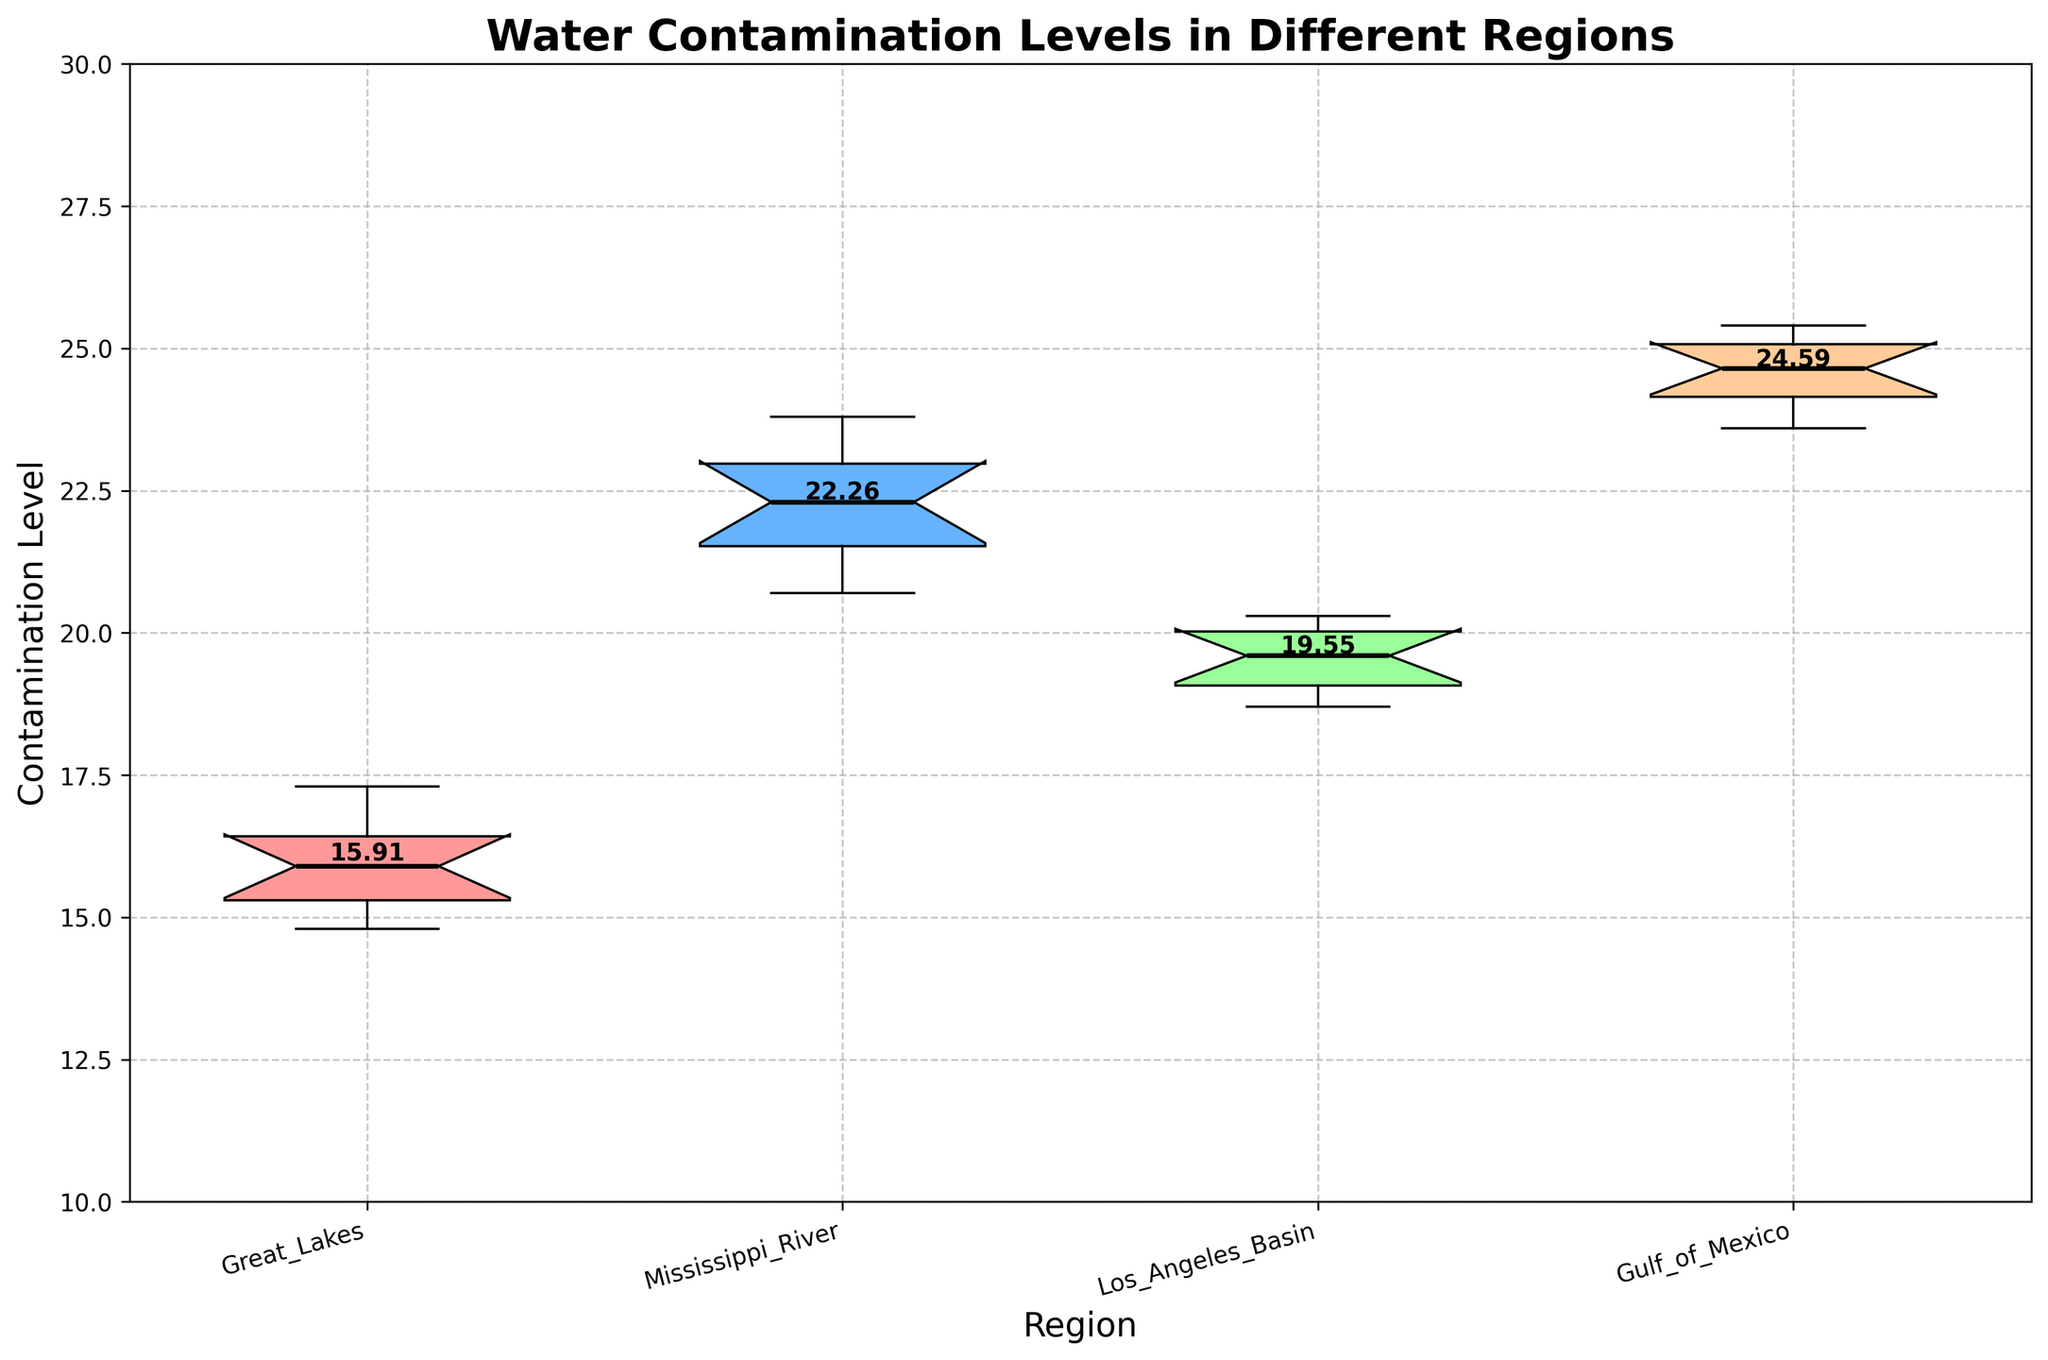What is the title of the figure? The title is written at the top of the figure and summarizes the content of the visualization.
Answer: Water Contamination Levels in Different Regions What is the contamination level at the median for the Great Lakes region? In a notched box plot, the median is indicated by the line inside the box and for the Great Lakes region, it is the middle of the first box from the left.
Answer: 16.0 Which region has the highest median contamination level? By looking at the lines inside the boxes, the Gulf of Mexico has the highest median, as it is the tallest among the medians of all regions.
Answer: Gulf of Mexico Which region has the lowest range of contamination levels? The range can be determined by the difference between the top and bottom of the box. The Great Lakes region has the smallest vertical span of the box, indicating the lowest range.
Answer: Great Lakes How do the average contamination levels compare between the Mississippi River and the Great Lakes regions? The average level for each region is indicated numerically above or below the box plot. The averages can be compared by noting the labels provided: Mississippi River (22.25) and Great Lakes (15.91).
Answer: Mississippi River has a higher average What is the interquartile range (IQR) for the Los Angeles Basin? The IQR is the difference between the third quartile (top of the box) and the first quartile (bottom of the box) in a box plot. For the Los Angeles Basin, identify these points visually from the box.
Answer: 1.3 (20.2 - 18.9) Which region shows the most variation in contamination levels? The most variation is often indicated by the widest spread from the bottom to the top whisker of the box plot. By checking, Gulf of Mexico has the widest spread.
Answer: Gulf of Mexico Are there any outliers in the data for any region? Outliers in a box plot are shown as individual points outside the whiskers. In this figure, no individual points outside the whiskers are visible for any region.
Answer: No What can be inferred about the contamination levels among the four regions? By examining positions and spreads of the notched box plots, Great Lakes has the lowest contamination levels and smallest range, Gulf of Mexico has the highest levels and widest range, and Mississippi River and Los Angeles Basin fall between them, with Mississippi River closer to Gulf of Mexico in contamination levels.
Answer: Inference: Great Lakes < Los Angeles Basin < Mississippi River < Gulf of Mexico 